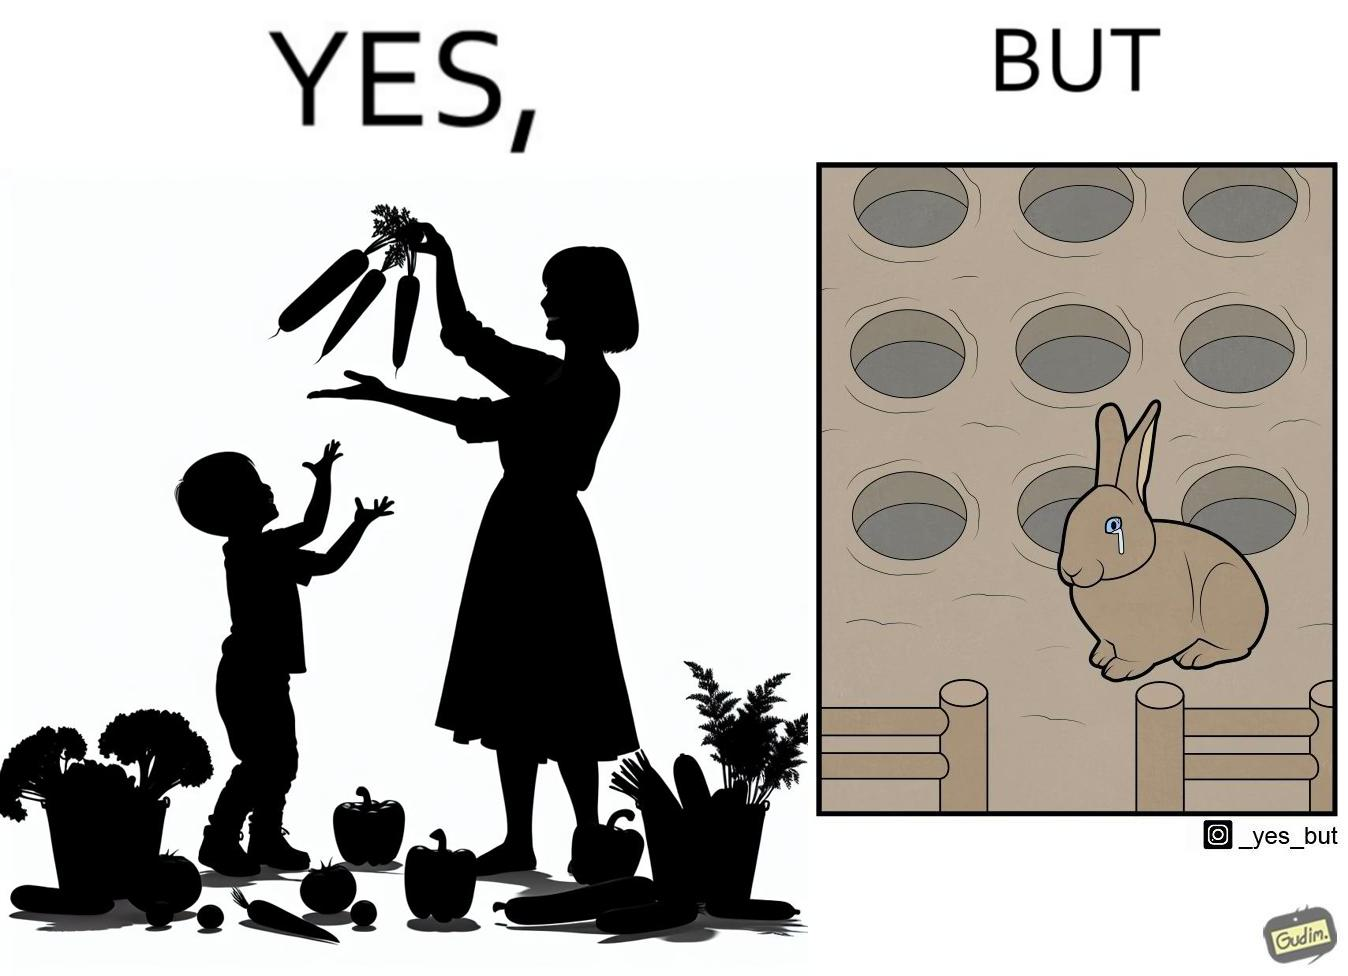What is the satirical meaning behind this image? The images are ironic since they show how on one hand humans choose to play with and waste foods like vegetables while the animals are unable to eat enough food and end up starving due to lack of food 